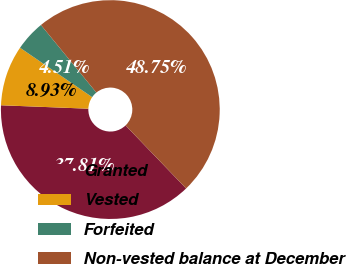Convert chart to OTSL. <chart><loc_0><loc_0><loc_500><loc_500><pie_chart><fcel>Granted<fcel>Vested<fcel>Forfeited<fcel>Non-vested balance at December<nl><fcel>37.81%<fcel>8.93%<fcel>4.51%<fcel>48.75%<nl></chart> 